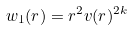<formula> <loc_0><loc_0><loc_500><loc_500>w _ { 1 } ( r ) = r ^ { 2 } v ( r ) ^ { 2 k }</formula> 